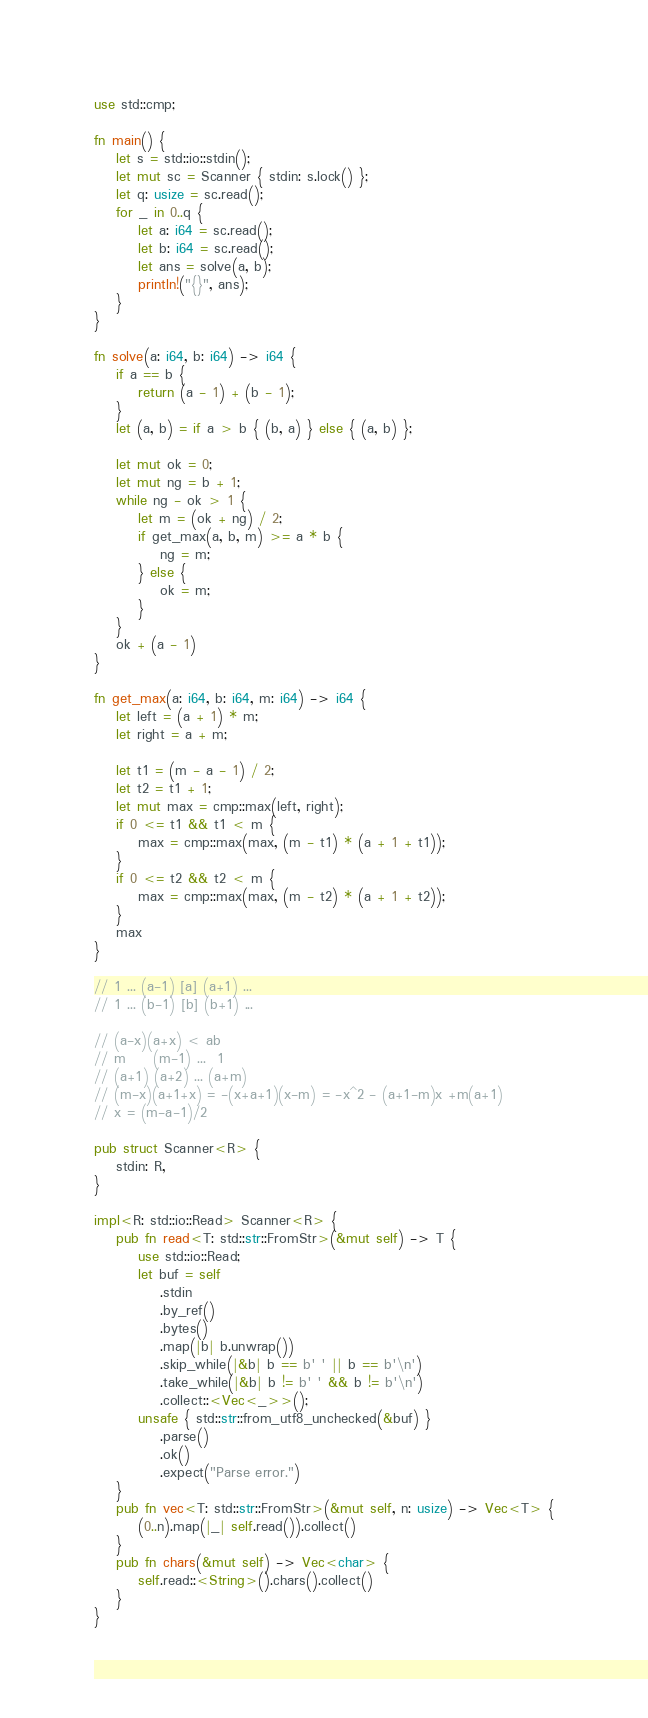Convert code to text. <code><loc_0><loc_0><loc_500><loc_500><_Rust_>use std::cmp;

fn main() {
    let s = std::io::stdin();
    let mut sc = Scanner { stdin: s.lock() };
    let q: usize = sc.read();
    for _ in 0..q {
        let a: i64 = sc.read();
        let b: i64 = sc.read();
        let ans = solve(a, b);
        println!("{}", ans);
    }
}

fn solve(a: i64, b: i64) -> i64 {
    if a == b {
        return (a - 1) + (b - 1);
    }
    let (a, b) = if a > b { (b, a) } else { (a, b) };

    let mut ok = 0;
    let mut ng = b + 1;
    while ng - ok > 1 {
        let m = (ok + ng) / 2;
        if get_max(a, b, m) >= a * b {
            ng = m;
        } else {
            ok = m;
        }
    }
    ok + (a - 1)
}

fn get_max(a: i64, b: i64, m: i64) -> i64 {
    let left = (a + 1) * m;
    let right = a + m;

    let t1 = (m - a - 1) / 2;
    let t2 = t1 + 1;
    let mut max = cmp::max(left, right);
    if 0 <= t1 && t1 < m {
        max = cmp::max(max, (m - t1) * (a + 1 + t1));
    }
    if 0 <= t2 && t2 < m {
        max = cmp::max(max, (m - t2) * (a + 1 + t2));
    }
    max
}

// 1 ... (a-1) [a] (a+1) ...
// 1 ... (b-1) [b] (b+1) ...

// (a-x)(a+x) < ab
// m     (m-1) ...  1
// (a+1) (a+2) ... (a+m)
// (m-x)(a+1+x) = -(x+a+1)(x-m) = -x^2 - (a+1-m)x +m(a+1)
// x = (m-a-1)/2

pub struct Scanner<R> {
    stdin: R,
}

impl<R: std::io::Read> Scanner<R> {
    pub fn read<T: std::str::FromStr>(&mut self) -> T {
        use std::io::Read;
        let buf = self
            .stdin
            .by_ref()
            .bytes()
            .map(|b| b.unwrap())
            .skip_while(|&b| b == b' ' || b == b'\n')
            .take_while(|&b| b != b' ' && b != b'\n')
            .collect::<Vec<_>>();
        unsafe { std::str::from_utf8_unchecked(&buf) }
            .parse()
            .ok()
            .expect("Parse error.")
    }
    pub fn vec<T: std::str::FromStr>(&mut self, n: usize) -> Vec<T> {
        (0..n).map(|_| self.read()).collect()
    }
    pub fn chars(&mut self) -> Vec<char> {
        self.read::<String>().chars().collect()
    }
}
</code> 